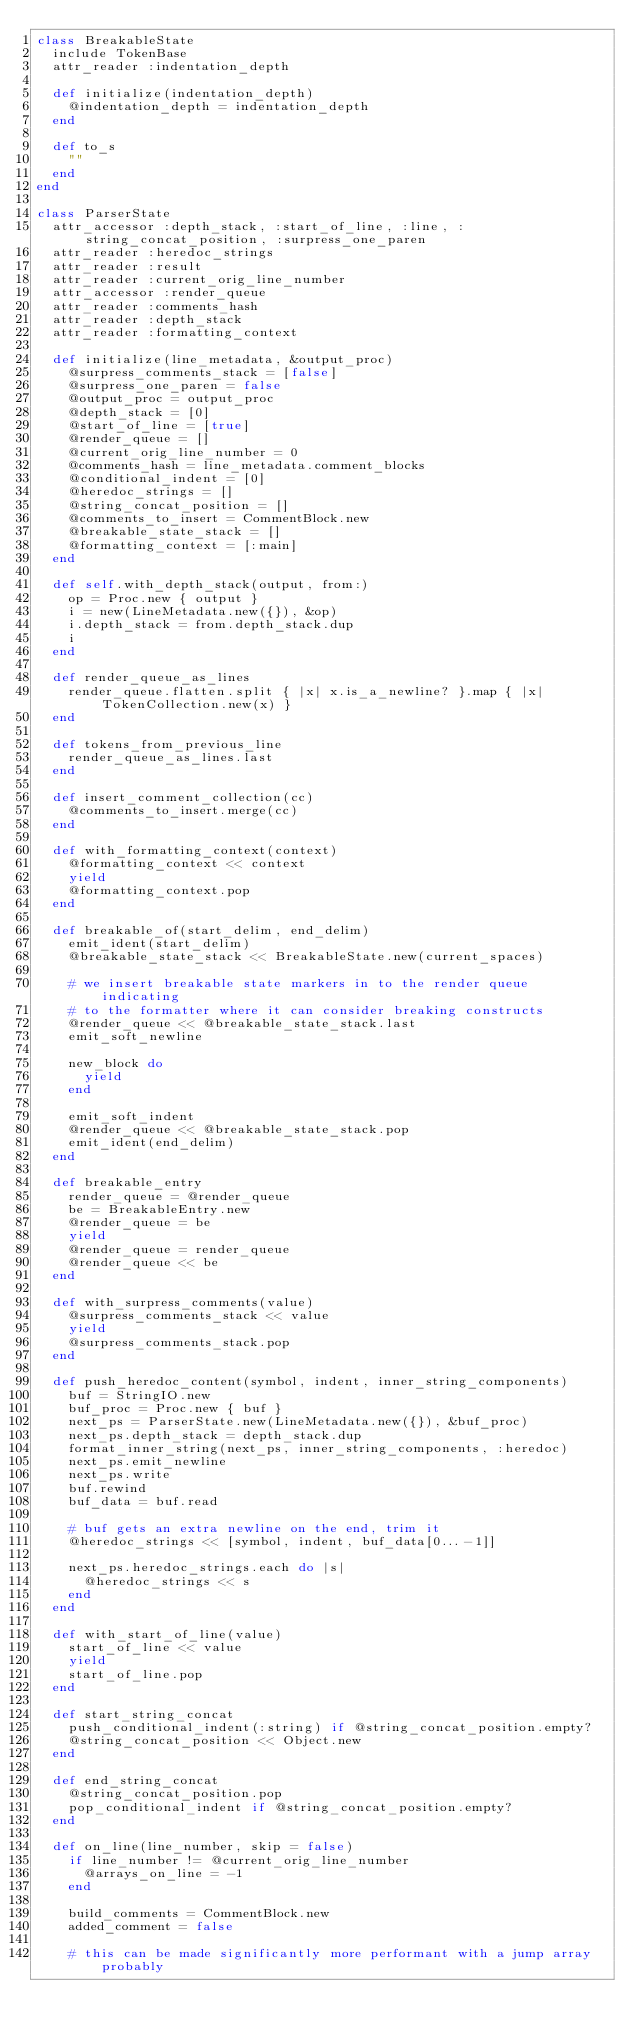<code> <loc_0><loc_0><loc_500><loc_500><_Ruby_>class BreakableState
  include TokenBase
  attr_reader :indentation_depth

  def initialize(indentation_depth)
    @indentation_depth = indentation_depth
  end

  def to_s
    ""
  end
end

class ParserState
  attr_accessor :depth_stack, :start_of_line, :line, :string_concat_position, :surpress_one_paren
  attr_reader :heredoc_strings
  attr_reader :result
  attr_reader :current_orig_line_number
  attr_accessor :render_queue
  attr_reader :comments_hash
  attr_reader :depth_stack
  attr_reader :formatting_context

  def initialize(line_metadata, &output_proc)
    @surpress_comments_stack = [false]
    @surpress_one_paren = false
    @output_proc = output_proc
    @depth_stack = [0]
    @start_of_line = [true]
    @render_queue = []
    @current_orig_line_number = 0
    @comments_hash = line_metadata.comment_blocks
    @conditional_indent = [0]
    @heredoc_strings = []
    @string_concat_position = []
    @comments_to_insert = CommentBlock.new
    @breakable_state_stack = []
    @formatting_context = [:main]
  end

  def self.with_depth_stack(output, from:)
    op = Proc.new { output }
    i = new(LineMetadata.new({}), &op)
    i.depth_stack = from.depth_stack.dup
    i
  end

  def render_queue_as_lines
    render_queue.flatten.split { |x| x.is_a_newline? }.map { |x| TokenCollection.new(x) }
  end

  def tokens_from_previous_line
    render_queue_as_lines.last
  end

  def insert_comment_collection(cc)
    @comments_to_insert.merge(cc)
  end

  def with_formatting_context(context)
    @formatting_context << context
    yield
    @formatting_context.pop
  end

  def breakable_of(start_delim, end_delim)
    emit_ident(start_delim)
    @breakable_state_stack << BreakableState.new(current_spaces)

    # we insert breakable state markers in to the render queue indicating
    # to the formatter where it can consider breaking constructs
    @render_queue << @breakable_state_stack.last
    emit_soft_newline

    new_block do
      yield
    end

    emit_soft_indent
    @render_queue << @breakable_state_stack.pop
    emit_ident(end_delim)
  end

  def breakable_entry
    render_queue = @render_queue
    be = BreakableEntry.new
    @render_queue = be
    yield
    @render_queue = render_queue
    @render_queue << be
  end

  def with_surpress_comments(value)
    @surpress_comments_stack << value
    yield
    @surpress_comments_stack.pop
  end

  def push_heredoc_content(symbol, indent, inner_string_components)
    buf = StringIO.new
    buf_proc = Proc.new { buf }
    next_ps = ParserState.new(LineMetadata.new({}), &buf_proc)
    next_ps.depth_stack = depth_stack.dup
    format_inner_string(next_ps, inner_string_components, :heredoc)
    next_ps.emit_newline
    next_ps.write
    buf.rewind
    buf_data = buf.read

    # buf gets an extra newline on the end, trim it
    @heredoc_strings << [symbol, indent, buf_data[0...-1]]

    next_ps.heredoc_strings.each do |s|
      @heredoc_strings << s
    end
  end

  def with_start_of_line(value)
    start_of_line << value
    yield
    start_of_line.pop
  end

  def start_string_concat
    push_conditional_indent(:string) if @string_concat_position.empty?
    @string_concat_position << Object.new
  end

  def end_string_concat
    @string_concat_position.pop
    pop_conditional_indent if @string_concat_position.empty?
  end

  def on_line(line_number, skip = false)
    if line_number != @current_orig_line_number
      @arrays_on_line = -1
    end

    build_comments = CommentBlock.new
    added_comment = false

    # this can be made significantly more performant with a jump array probably</code> 